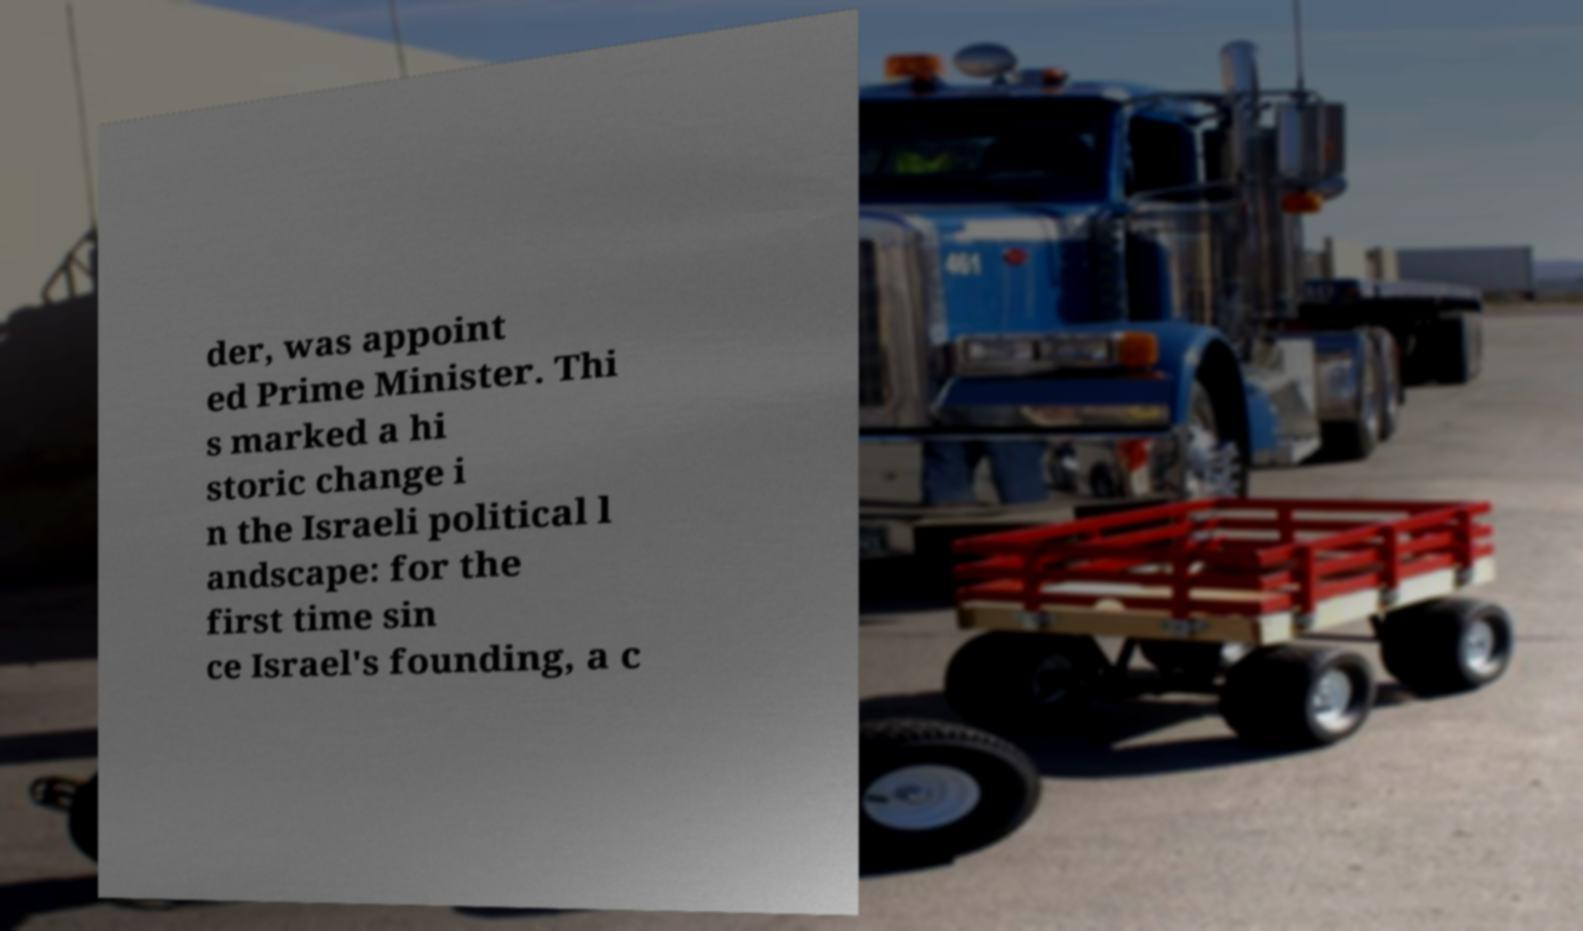Can you accurately transcribe the text from the provided image for me? der, was appoint ed Prime Minister. Thi s marked a hi storic change i n the Israeli political l andscape: for the first time sin ce Israel's founding, a c 